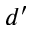Convert formula to latex. <formula><loc_0><loc_0><loc_500><loc_500>d ^ { \prime }</formula> 